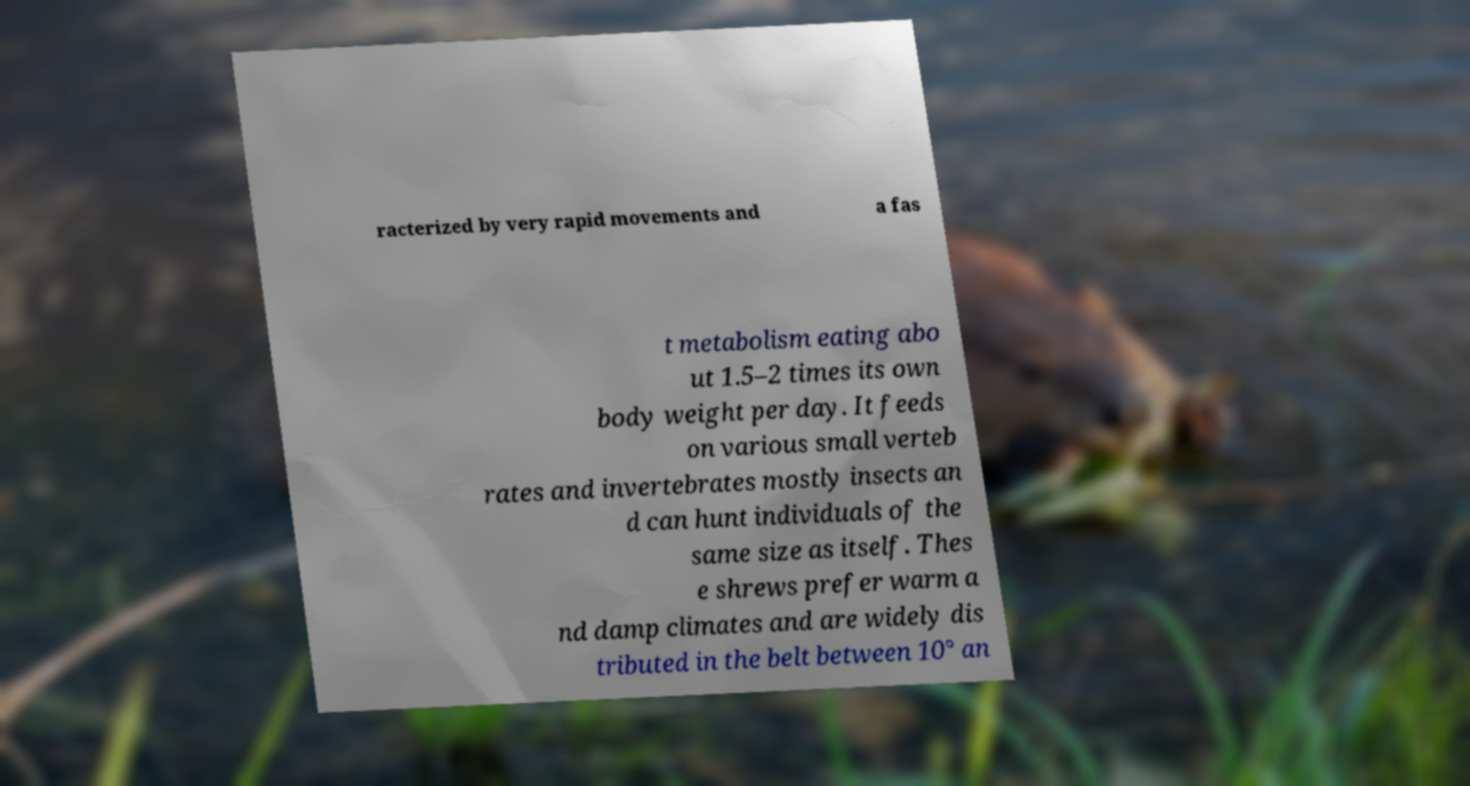Could you assist in decoding the text presented in this image and type it out clearly? racterized by very rapid movements and a fas t metabolism eating abo ut 1.5–2 times its own body weight per day. It feeds on various small verteb rates and invertebrates mostly insects an d can hunt individuals of the same size as itself. Thes e shrews prefer warm a nd damp climates and are widely dis tributed in the belt between 10° an 